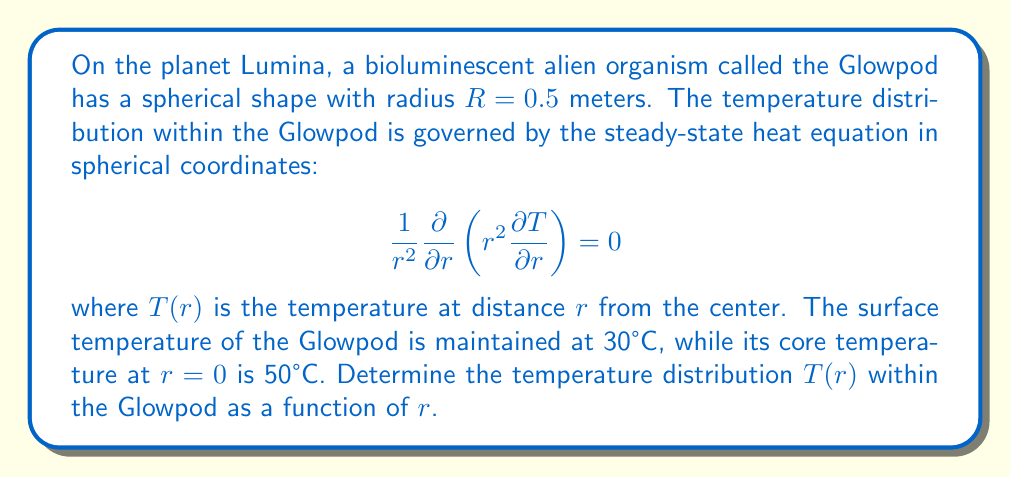Could you help me with this problem? To solve this problem, we'll follow these steps:

1) The general solution to the steady-state heat equation in spherical coordinates is:

   $$T(r) = A + \frac{B}{r}$$

   where $A$ and $B$ are constants we need to determine.

2) We have two boundary conditions:
   - At $r = 0$ (core), $T(0) = 50°C$
   - At $r = R = 0.5m$ (surface), $T(0.5) = 30°C$

3) Let's apply the first boundary condition. As $r$ approaches 0, $\frac{B}{r}$ would approach infinity unless $B = 0$. Therefore, at $r = 0$:

   $$50 = A + \frac{B}{0} \implies A = 50$$

4) Now, let's apply the second boundary condition:

   $$30 = A + \frac{B}{0.5}$$

5) Substitute $A = 50$ from step 3:

   $$30 = 50 + \frac{B}{0.5}$$

6) Solve for $B$:

   $$B = 0.5 \times (30 - 50) = -10$$

7) Therefore, the temperature distribution is:

   $$T(r) = 50 - \frac{10}{r}$$

This equation describes how the temperature changes from the core to the surface of the Glowpod.
Answer: $T(r) = 50 - \frac{10}{r}$ 